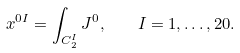<formula> <loc_0><loc_0><loc_500><loc_500>x ^ { 0 I } = \int _ { C _ { 2 } ^ { I } } J ^ { 0 } , \quad I = 1 , \dots , 2 0 .</formula> 